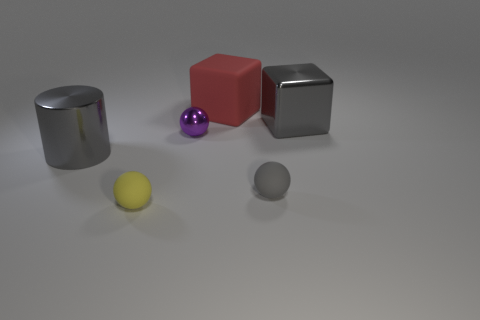There is another big metal thing that is the same shape as the red object; what is its color?
Offer a terse response. Gray. Is the color of the large metallic object left of the shiny cube the same as the large metallic block?
Provide a short and direct response. Yes. How many gray metal blocks are there?
Your answer should be compact. 1. Is the material of the gray thing that is left of the red rubber object the same as the large gray block?
Give a very brief answer. Yes. What number of big gray things are behind the cube to the right of the matte object that is behind the shiny cube?
Provide a short and direct response. 0. How big is the gray metal cube?
Offer a terse response. Large. Is the large metal cylinder the same color as the metallic cube?
Ensure brevity in your answer.  Yes. There is a metal sphere that is behind the tiny gray object; how big is it?
Offer a terse response. Small. There is a big object that is in front of the gray metallic block; is it the same color as the big metallic object that is behind the gray metal cylinder?
Keep it short and to the point. Yes. How many other things are the same shape as the tiny yellow rubber thing?
Provide a short and direct response. 2. 